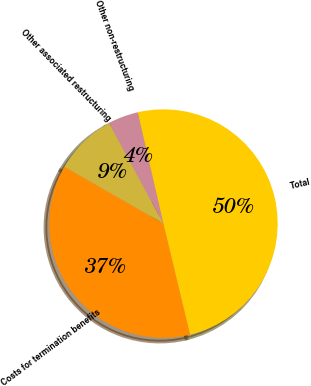Convert chart. <chart><loc_0><loc_0><loc_500><loc_500><pie_chart><fcel>Costs for termination benefits<fcel>Other associated restructuring<fcel>Other non-restructuring<fcel>Total<nl><fcel>37.04%<fcel>8.83%<fcel>4.27%<fcel>49.86%<nl></chart> 